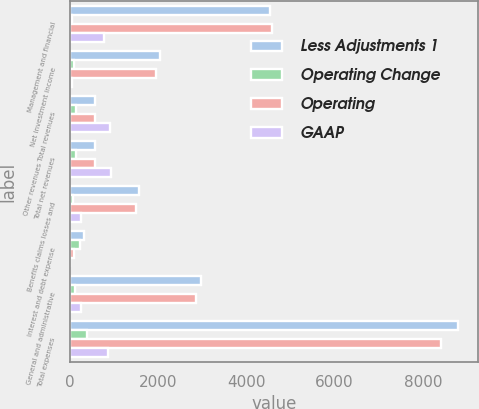Convert chart to OTSL. <chart><loc_0><loc_0><loc_500><loc_500><stacked_bar_chart><ecel><fcel>Management and financial<fcel>Net investment income<fcel>Other revenues Total revenues<fcel>Total net revenues<fcel>Benefits claims losses and<fcel>Interest and debt expense<fcel>General and administrative<fcel>Total expenses<nl><fcel>Less Adjustments 1<fcel>4537<fcel>2046<fcel>580<fcel>580<fcel>1557<fcel>317<fcel>2965<fcel>8807<nl><fcel>Operating Change<fcel>49<fcel>97<fcel>142<fcel>142<fcel>67<fcel>221<fcel>116<fcel>396<nl><fcel>Operating<fcel>4586<fcel>1949<fcel>580<fcel>580<fcel>1490<fcel>96<fcel>2849<fcel>8411<nl><fcel>GAAP<fcel>764<fcel>52<fcel>910<fcel>933<fcel>251<fcel>13<fcel>241<fcel>868<nl></chart> 